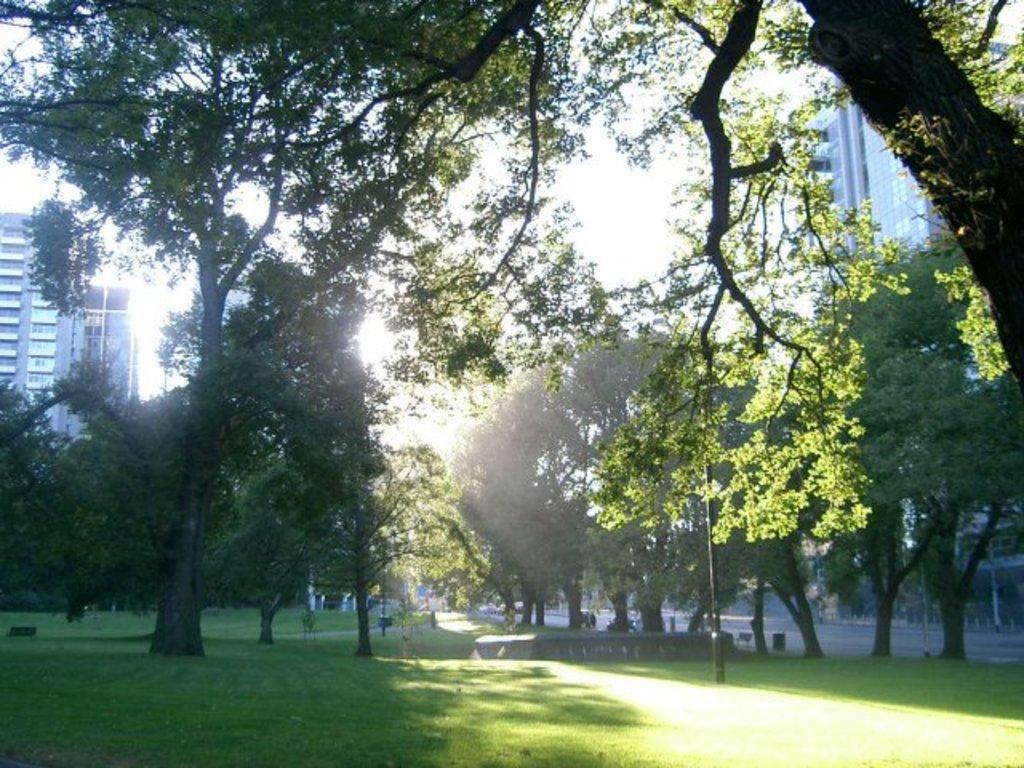Can you describe this image briefly? In this image I can see trees in green color, at left and right I can see two buildings in white color, at top sky is in white color. 